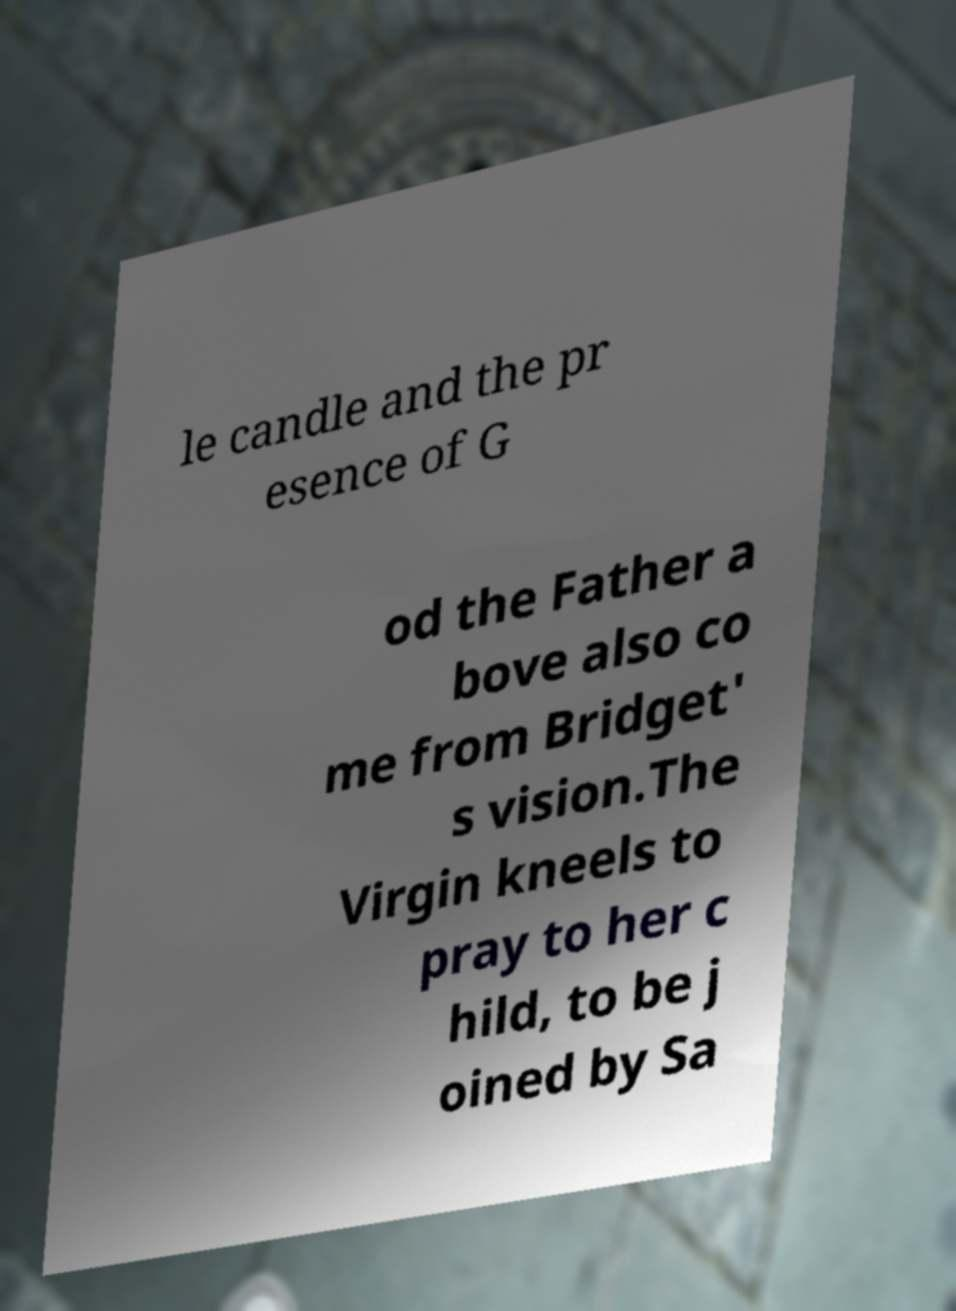Please read and relay the text visible in this image. What does it say? le candle and the pr esence of G od the Father a bove also co me from Bridget' s vision.The Virgin kneels to pray to her c hild, to be j oined by Sa 